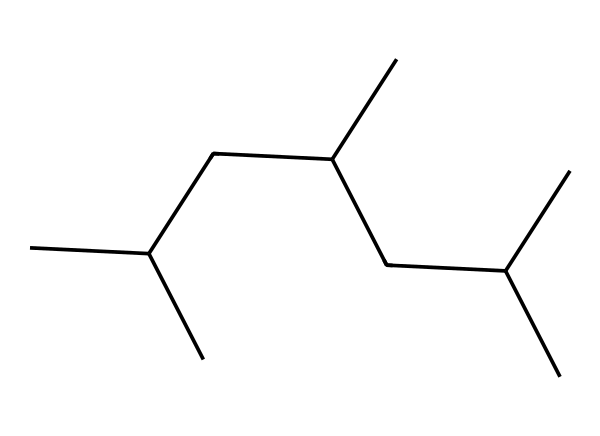what is the chemical name of this structure? The SMILES representation CC(C)CC(C)CC(C)C indicates a chain of carbon atoms with branching, characteristic of polypropylene. Polypropylene is a common plastic known for its durability and is often used in food containers.
Answer: polypropylene how many carbon atoms are present in this molecule? By analyzing the SMILES structure, each 'C' represents a carbon atom. Counting the carbon atoms in the notation CC(C)CC(C)CC(C)C shows that there are 12 carbon atoms in total.
Answer: 12 what type of polymer is represented by this chemical structure? The structure represents a type of thermoplastic polymer known as polypropylene. Thermoplastics can be reshaped upon heating, making them useful for various applications, including food containers.
Answer: thermoplastic how many branches are present in this chemical structure? In the given SMILES, there are indications of branching with the '(C)' groups. Each branch is counted separately, giving a total of three branches in the molecule.
Answer: 3 what characteristic makes this polymer suitable for food containers? The long carbon chains and branched structure of polypropylene create a strong and durable material that is resistant to heat and moisture, making it ideal for food storage.
Answer: durability how does the structure contribute to the rigidity of this plastic? The regular arrangement of carbon atoms allows for strong intermolecular forces between the chains, which enhances rigidity. The branching prevents tight packing, affecting flexibility and strength.
Answer: strong intermolecular forces 